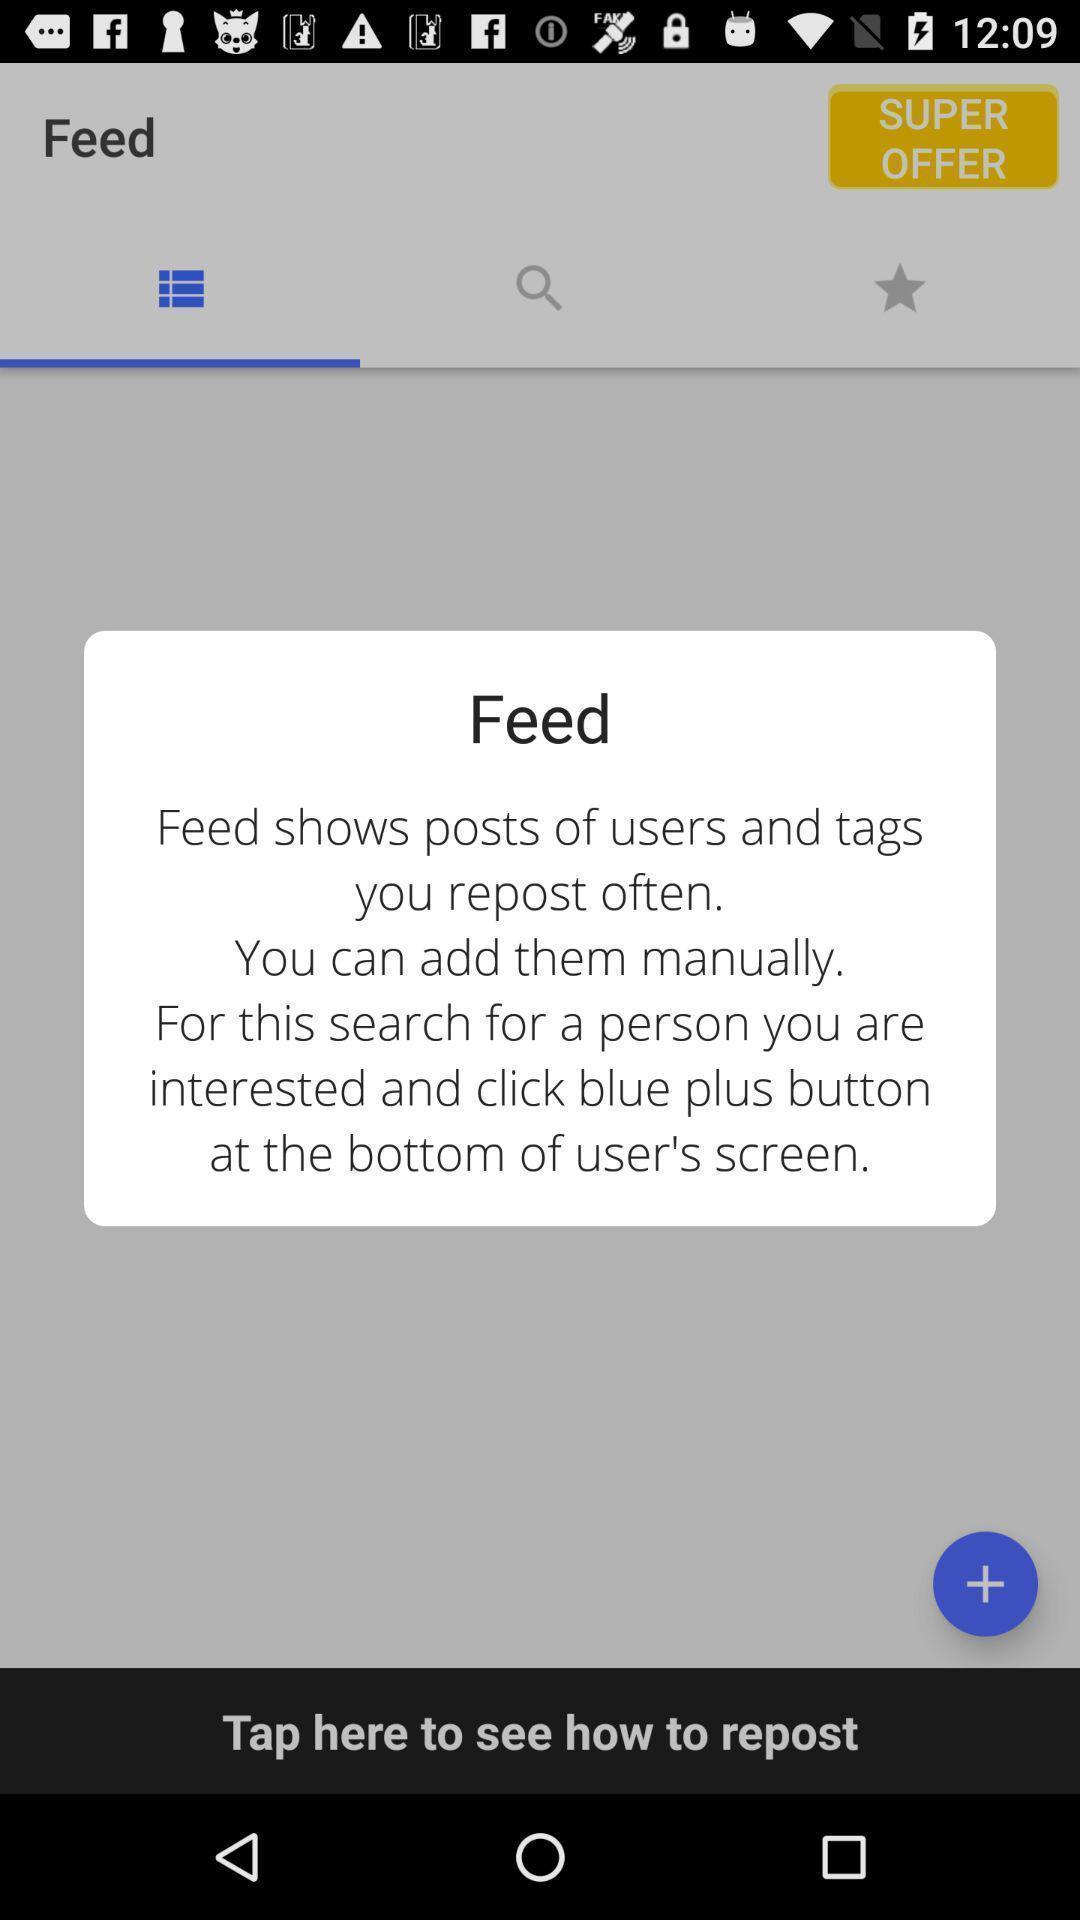Summarize the information in this screenshot. Popup showing information about feed. 